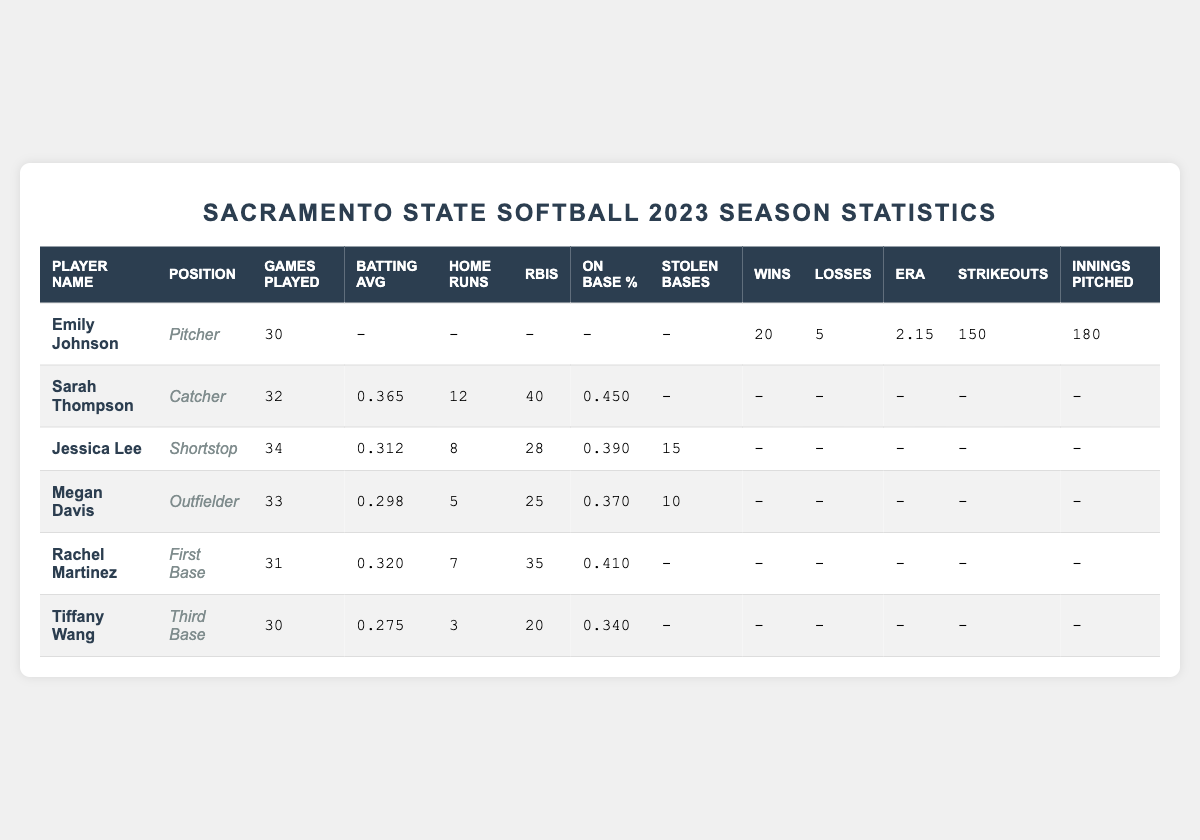What is Emily Johnson's earned run average (ERA)? The table lists Emily Johnson's earned run average under her statistics, which shows a value of 2.15.
Answer: 2.15 How many wins does Sarah Thompson have? The table does not provide information on wins for Sarah Thompson, as she is a catcher and not a pitcher.
Answer: Not applicable Which player has the highest batting average? By comparing the batting averages listed in the table, Sarah Thompson has the highest batting average of 0.365.
Answer: 0.365 How many home runs did Jessica Lee hit? The table indicates that Jessica Lee hit 8 home runs during the season.
Answer: 8 What is the total number of RBIs for Rachel Martinez and Megan Davis combined? Rachel Martinez has 35 RBIs and Megan Davis has 25 RBIs. Adding them together gives 35 + 25 = 60.
Answer: 60 Did Tiffany Wang have any stolen bases? The table shows a dash "-" under stolen bases for Tiffany Wang, indicating she had zero stolen bases.
Answer: No How many games did Jessica Lee play compared to Tiffany Wang? Jessica Lee played 34 games and Tiffany Wang played 30 games. Jessica Lee played 4 more games than Tiffany Wang (34 - 30 = 4).
Answer: 4 more games What is the average batting average of all players listed? The batting averages are 0.365 (Sarah), 0.312 (Jessica), 0.298 (Megan), 0.320 (Rachel), and 0.275 (Tiffany). Sum = 0.365 + 0.312 + 0.298 + 0.320 + 0.275 = 1.570. Divide by 5 gives an average of 1.570 / 5 = 0.314.
Answer: 0.314 Which player has the most strikeouts? The table shows Emily Johnson with 150 strikeouts, while other players do not have strikeouts listed as they are non-pitchers. Therefore, Emily Johnson has the most.
Answer: Emily Johnson Is Rachel Martinez's on-base percentage higher than Tiffany Wang's? Rachel Martinez has an on-base percentage of 0.410 and Tiffany Wang has 0.340. Since 0.410 is greater than 0.340, Rachel's on-base percentage is indeed higher.
Answer: Yes How many strikeouts does Emily Johnson have compared to the combined strikeouts of Jessica Lee and Megan Davis? Emily has 150 strikeouts. Jessica and Megan have zero strikeouts as non-pitchers, so the total strikeouts for Jessica and Megan is 0.
Answer: 150 